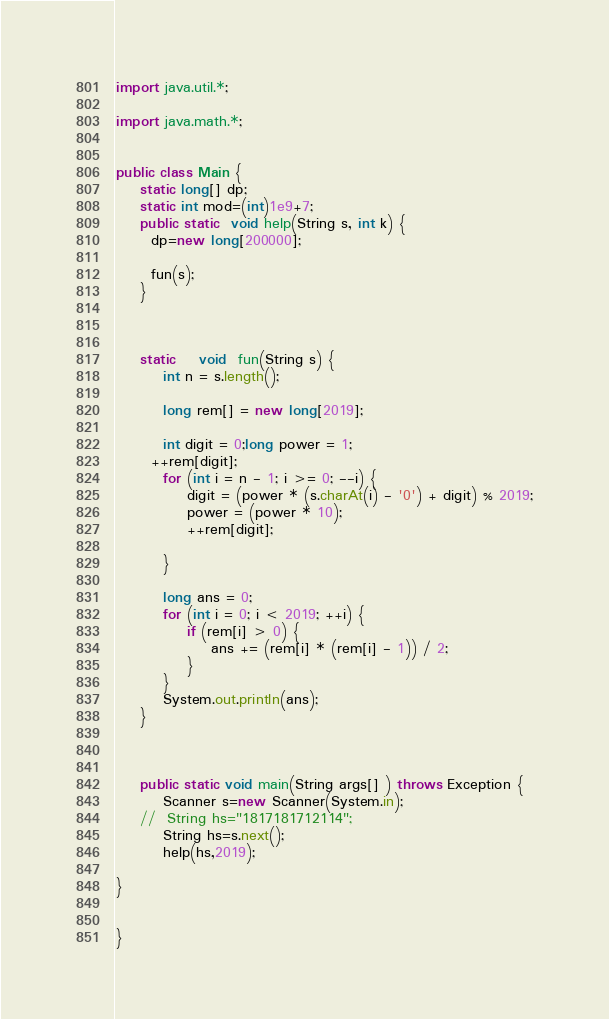<code> <loc_0><loc_0><loc_500><loc_500><_Java_>
import java.util.*;

import java.math.*;


public class Main { 
	static long[] dp;
    static int mod=(int)1e9+7;
    public static  void help(String s, int k) {
      dp=new long[200000];
     
      fun(s);
    }
    
    
 
    static	void  fun(String s) {
		int n = s.length();

		long rem[] = new long[2019];
	
		int digit = 0;long power = 1;
      ++rem[digit];
		for (int i = n - 1; i >= 0; --i) {
			digit = (power * (s.charAt(i) - '0') + digit) % 2019;
			power = (power * 10);
			++rem[digit];

		}
		
		long ans = 0;
		for (int i = 0; i < 2019; ++i) {
			if (rem[i] > 0) {
				ans += (rem[i] * (rem[i] - 1)) / 2;
			}
		}
		System.out.println(ans);
	}

   
	    
	public static void main(String args[] ) throws Exception {
		Scanner s=new Scanner(System.in);
	//	String hs="1817181712114";
		String hs=s.next();
		help(hs,2019);
		
}


} 
</code> 